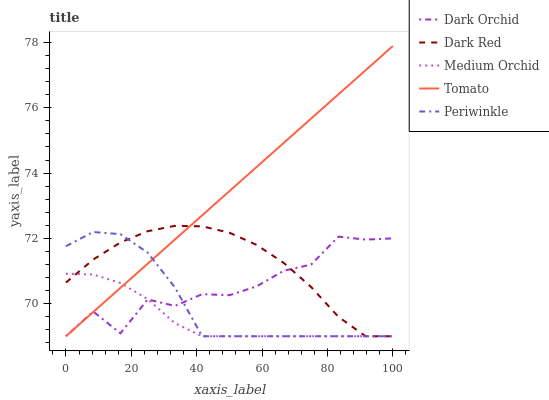Does Dark Red have the minimum area under the curve?
Answer yes or no. No. Does Dark Red have the maximum area under the curve?
Answer yes or no. No. Is Dark Red the smoothest?
Answer yes or no. No. Is Dark Red the roughest?
Answer yes or no. No. Does Dark Red have the highest value?
Answer yes or no. No. 